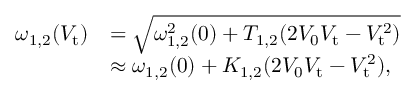Convert formula to latex. <formula><loc_0><loc_0><loc_500><loc_500>\begin{array} { r l } { \omega _ { 1 , 2 } ( V _ { t } ) } & { = \sqrt { \omega _ { 1 , 2 } ^ { 2 } ( 0 ) + T _ { 1 , 2 } ( 2 V _ { 0 } V _ { t } - V _ { t } ^ { 2 } ) } } \\ & { \approx \omega _ { 1 , 2 } ( 0 ) + K _ { 1 , 2 } ( 2 V _ { 0 } V _ { t } - V _ { t } ^ { 2 } ) , } \end{array}</formula> 